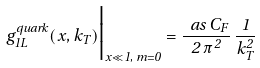Convert formula to latex. <formula><loc_0><loc_0><loc_500><loc_500>g _ { 1 L } ^ { q u a r k } ( x , k _ { T } ) \Big | _ { x \ll 1 , \, m = 0 } = \frac { \ a s \, C _ { F } } { 2 \, \pi ^ { 2 } } \, \frac { 1 } { k _ { T } ^ { 2 } }</formula> 